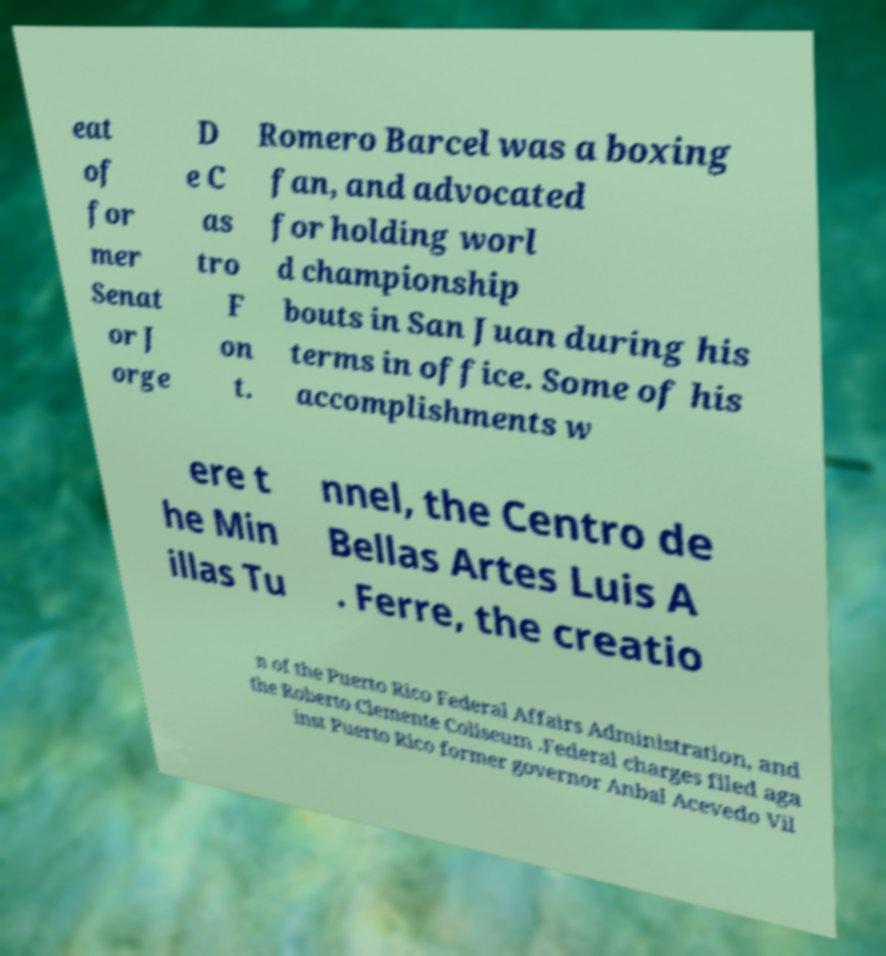Could you extract and type out the text from this image? eat of for mer Senat or J orge D e C as tro F on t. Romero Barcel was a boxing fan, and advocated for holding worl d championship bouts in San Juan during his terms in office. Some of his accomplishments w ere t he Min illas Tu nnel, the Centro de Bellas Artes Luis A . Ferre, the creatio n of the Puerto Rico Federal Affairs Administration, and the Roberto Clemente Coliseum .Federal charges filed aga inst Puerto Rico former governor Anbal Acevedo Vil 